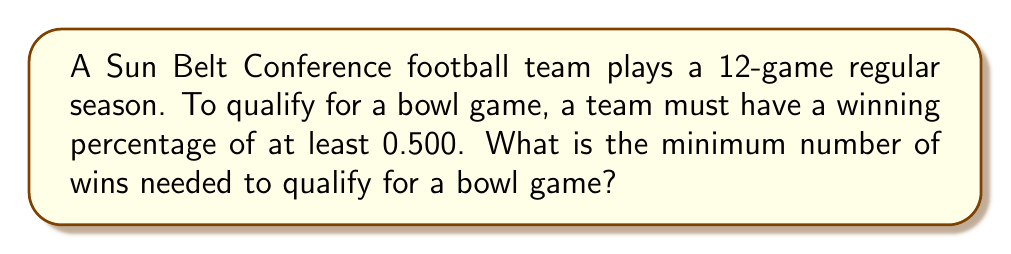Can you answer this question? Let's approach this step-by-step:

1) First, we need to set up an inequality to represent the winning percentage:

   $\frac{\text{wins}}{\text{total games}} \geq 0.500$

2) We know the total number of games is 12, so we can substitute this:

   $\frac{\text{wins}}{12} \geq 0.500$

3) Let's represent the number of wins with a variable, $x$:

   $\frac{x}{12} \geq 0.500$

4) To solve this inequality, we multiply both sides by 12:

   $x \geq 12 \cdot 0.500$

5) Simplify:

   $x \geq 6$

6) Since $x$ represents the number of wins, it must be a whole number. Therefore, the minimum number of wins is the smallest whole number greater than or equal to 6.

7) In this case, 6 itself is a whole number, so that's our answer.
Answer: 6 wins 